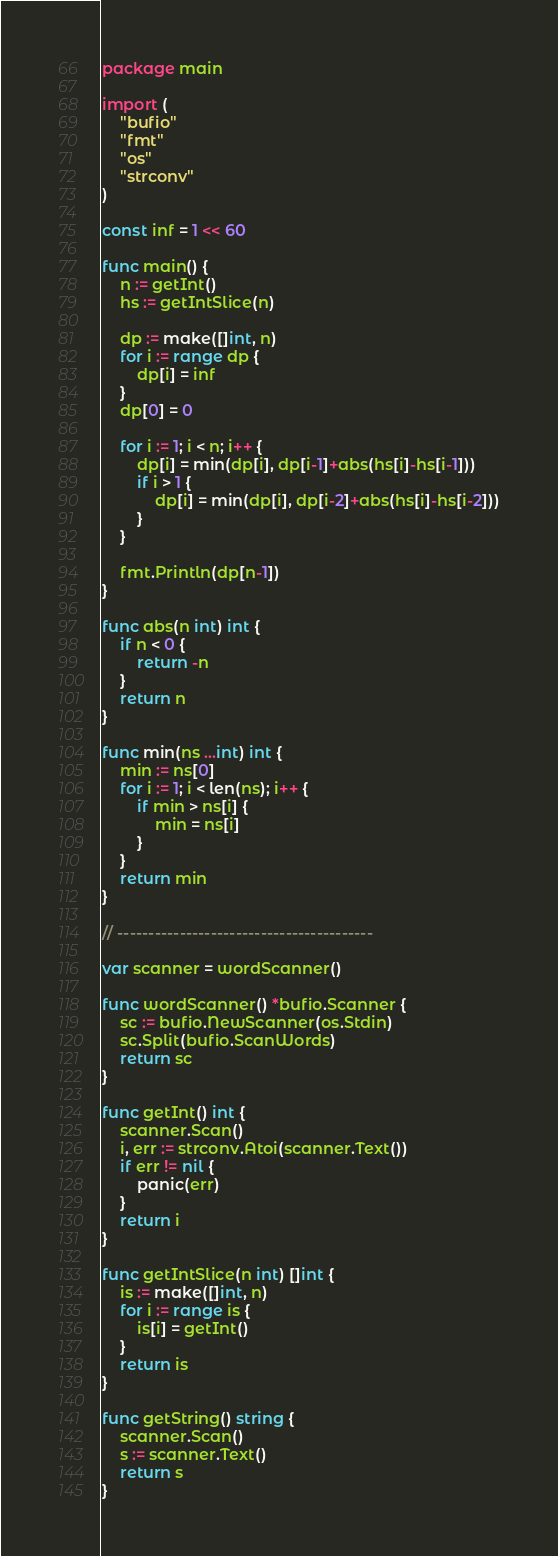Convert code to text. <code><loc_0><loc_0><loc_500><loc_500><_Go_>package main

import (
	"bufio"
	"fmt"
	"os"
	"strconv"
)

const inf = 1 << 60

func main() {
	n := getInt()
	hs := getIntSlice(n)

	dp := make([]int, n)
	for i := range dp {
		dp[i] = inf
	}
	dp[0] = 0

	for i := 1; i < n; i++ {
		dp[i] = min(dp[i], dp[i-1]+abs(hs[i]-hs[i-1]))
		if i > 1 {
			dp[i] = min(dp[i], dp[i-2]+abs(hs[i]-hs[i-2]))
		}
	}

	fmt.Println(dp[n-1])
}

func abs(n int) int {
	if n < 0 {
		return -n
	}
	return n
}

func min(ns ...int) int {
	min := ns[0]
	for i := 1; i < len(ns); i++ {
		if min > ns[i] {
			min = ns[i]
		}
	}
	return min
}

// -----------------------------------------

var scanner = wordScanner()

func wordScanner() *bufio.Scanner {
	sc := bufio.NewScanner(os.Stdin)
	sc.Split(bufio.ScanWords)
	return sc
}

func getInt() int {
	scanner.Scan()
	i, err := strconv.Atoi(scanner.Text())
	if err != nil {
		panic(err)
	}
	return i
}

func getIntSlice(n int) []int {
	is := make([]int, n)
	for i := range is {
		is[i] = getInt()
	}
	return is
}

func getString() string {
	scanner.Scan()
	s := scanner.Text()
	return s
}
</code> 